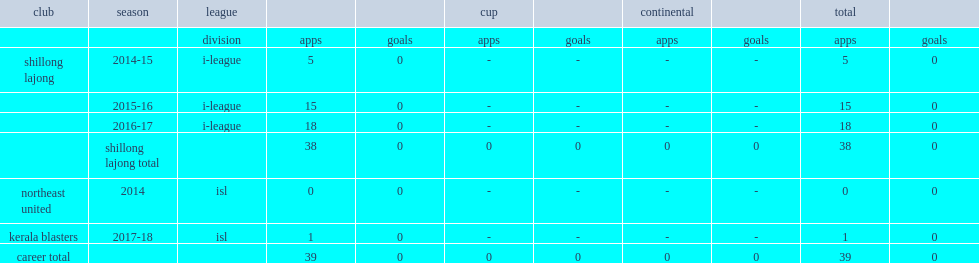In the 2015-16, which league was singh part of the shillong lajong? I-league. 